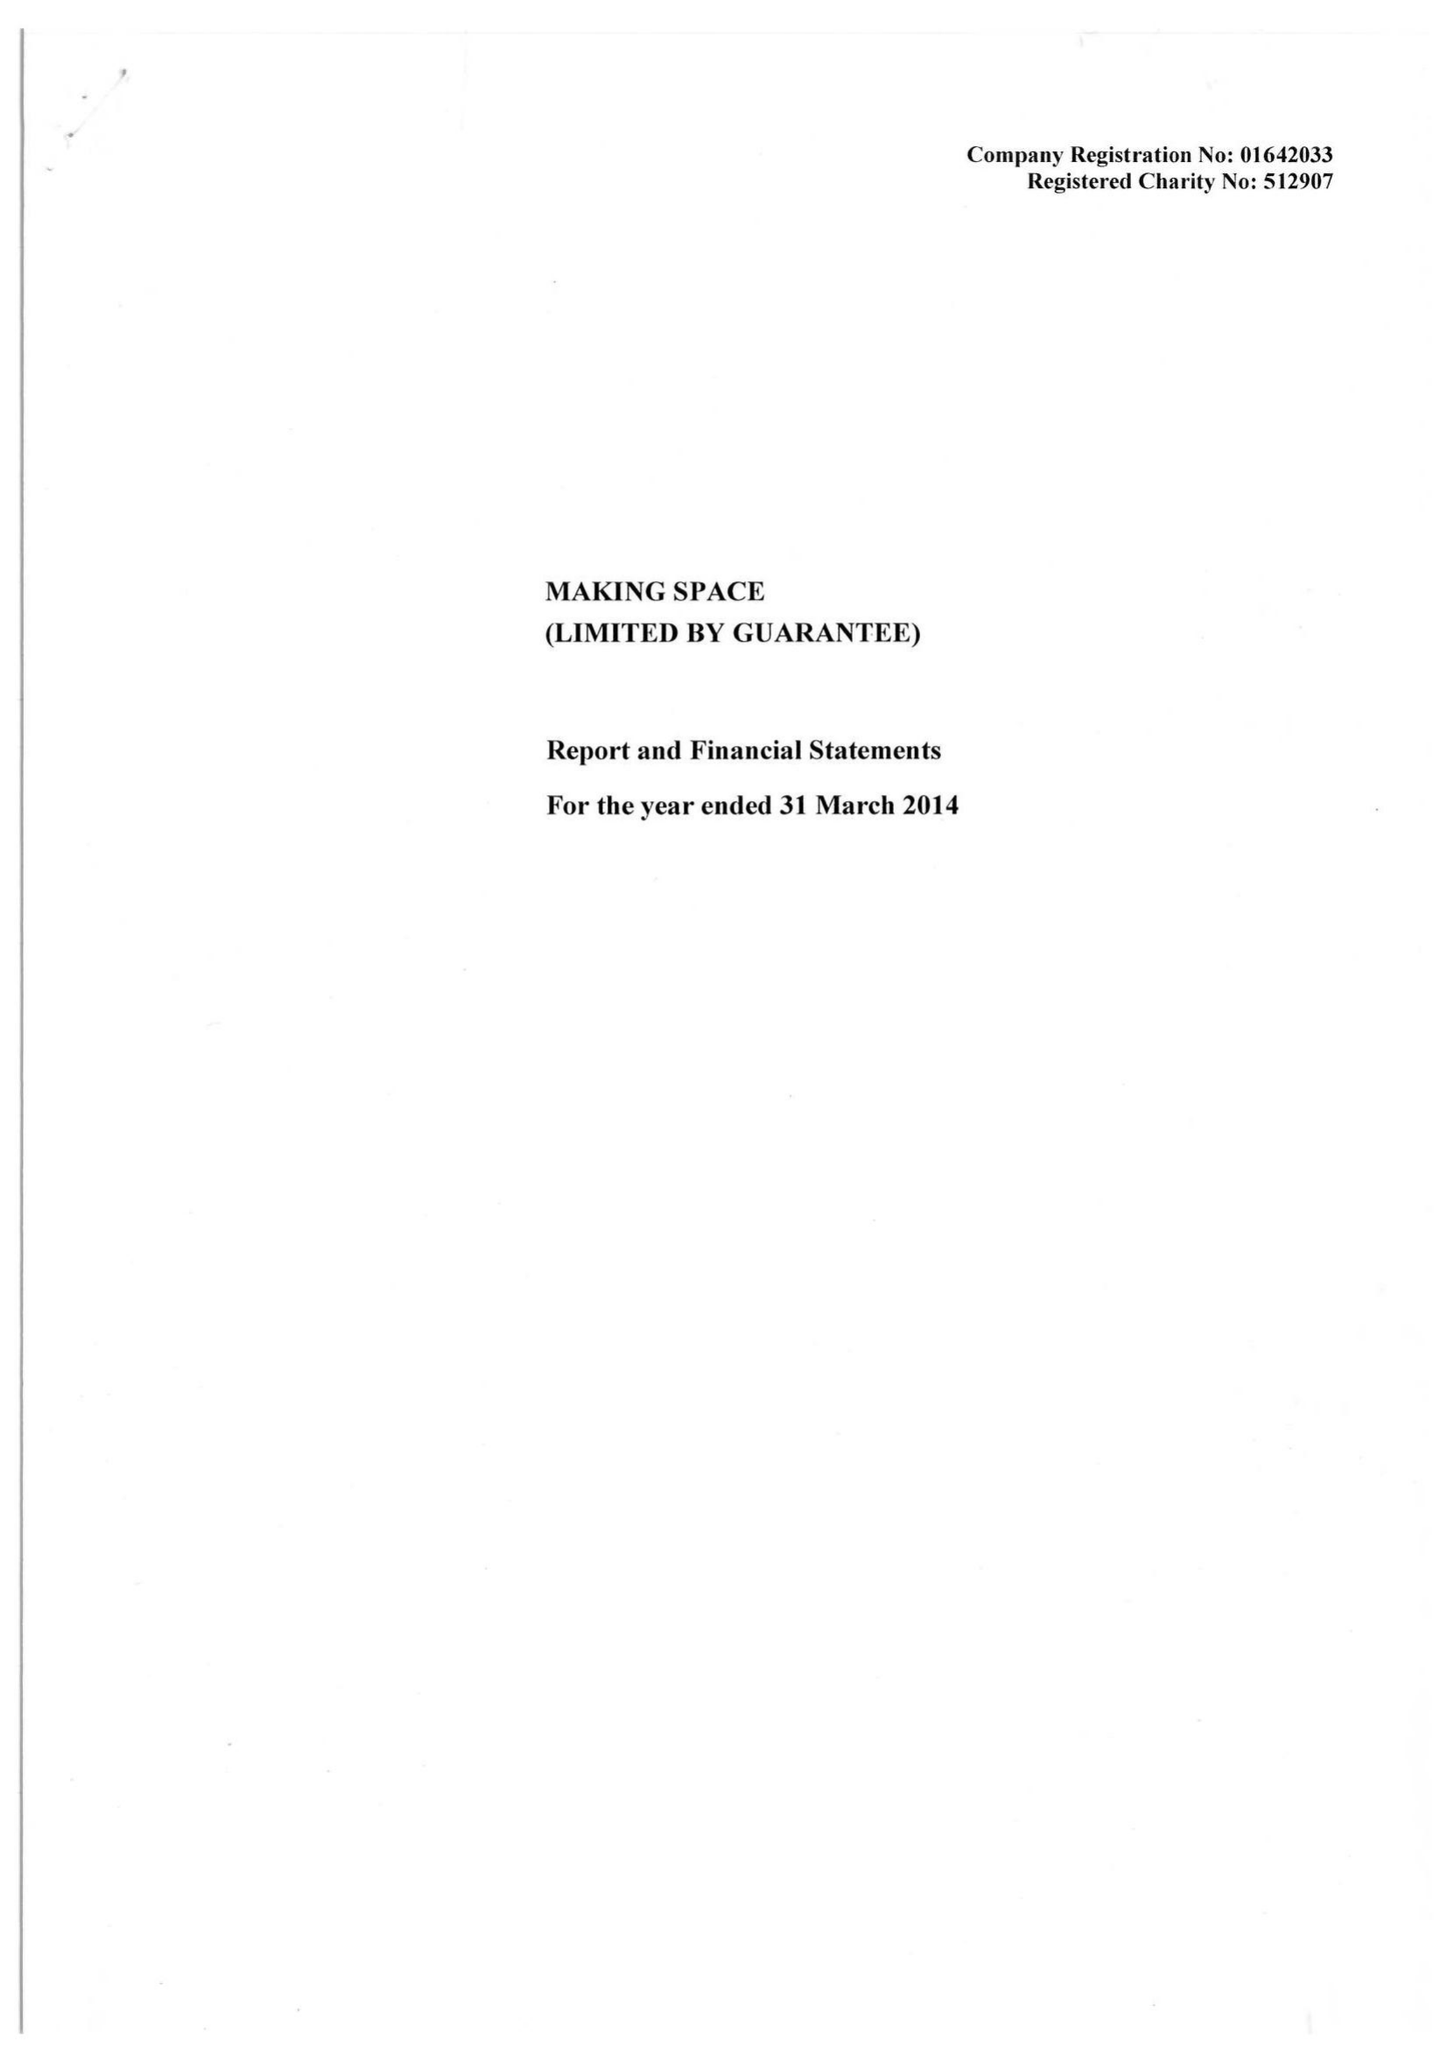What is the value for the spending_annually_in_british_pounds?
Answer the question using a single word or phrase. 20724735.00 